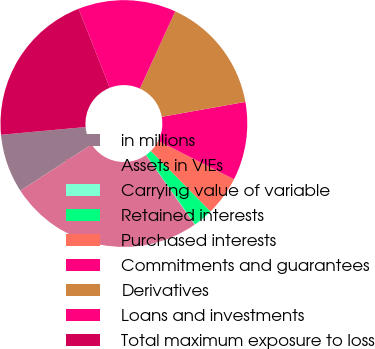<chart> <loc_0><loc_0><loc_500><loc_500><pie_chart><fcel>in millions<fcel>Assets in VIEs<fcel>Carrying value of variable<fcel>Retained interests<fcel>Purchased interests<fcel>Commitments and guarantees<fcel>Derivatives<fcel>Loans and investments<fcel>Total maximum exposure to loss<nl><fcel>7.71%<fcel>25.58%<fcel>0.05%<fcel>2.6%<fcel>5.16%<fcel>10.26%<fcel>15.37%<fcel>12.81%<fcel>20.47%<nl></chart> 